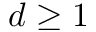Convert formula to latex. <formula><loc_0><loc_0><loc_500><loc_500>d \geq 1</formula> 